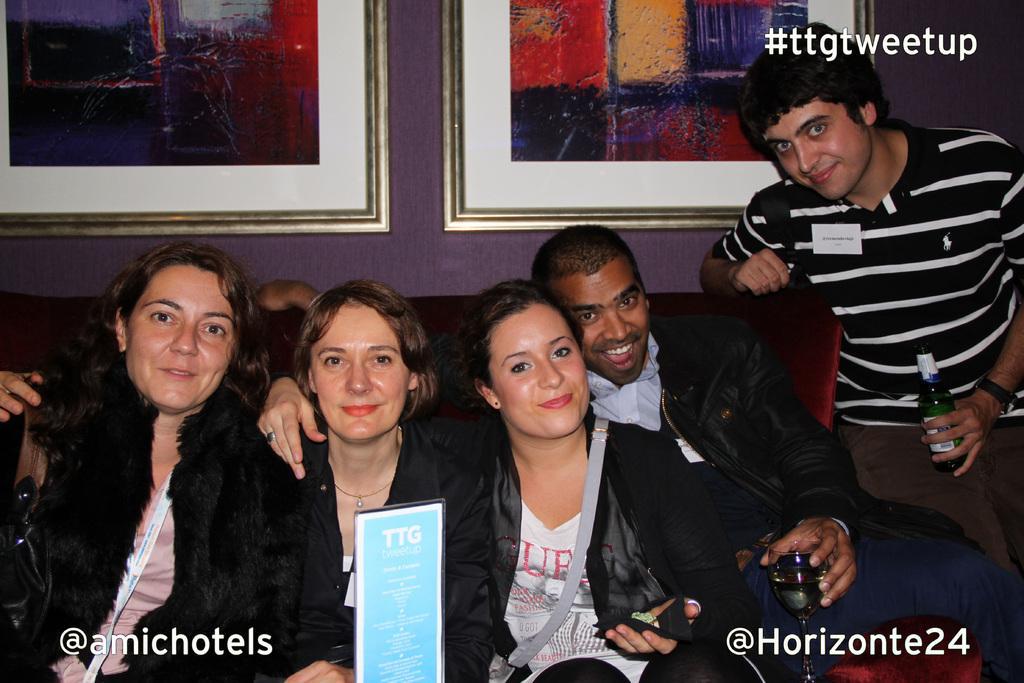Describe this image in one or two sentences. In the center of the image we can see a few people are sitting and they are smiling and they are in different costumes. Among them, we can see three persons are holding some objects. In front of them, we can see one board with some text. At the bottom of the image we can see some text. In the background there is a wall, frames and some text. 